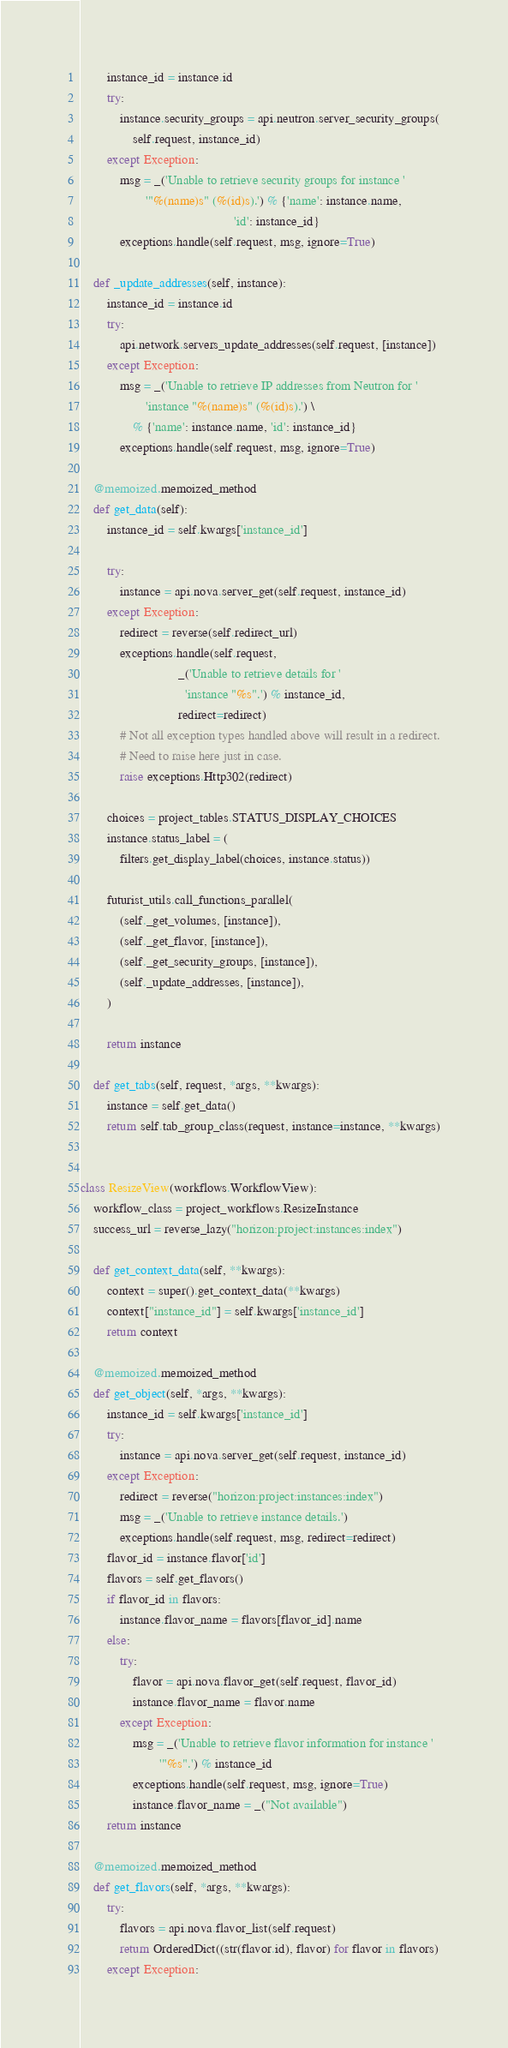<code> <loc_0><loc_0><loc_500><loc_500><_Python_>        instance_id = instance.id
        try:
            instance.security_groups = api.neutron.server_security_groups(
                self.request, instance_id)
        except Exception:
            msg = _('Unable to retrieve security groups for instance '
                    '"%(name)s" (%(id)s).') % {'name': instance.name,
                                               'id': instance_id}
            exceptions.handle(self.request, msg, ignore=True)

    def _update_addresses(self, instance):
        instance_id = instance.id
        try:
            api.network.servers_update_addresses(self.request, [instance])
        except Exception:
            msg = _('Unable to retrieve IP addresses from Neutron for '
                    'instance "%(name)s" (%(id)s).') \
                % {'name': instance.name, 'id': instance_id}
            exceptions.handle(self.request, msg, ignore=True)

    @memoized.memoized_method
    def get_data(self):
        instance_id = self.kwargs['instance_id']

        try:
            instance = api.nova.server_get(self.request, instance_id)
        except Exception:
            redirect = reverse(self.redirect_url)
            exceptions.handle(self.request,
                              _('Unable to retrieve details for '
                                'instance "%s".') % instance_id,
                              redirect=redirect)
            # Not all exception types handled above will result in a redirect.
            # Need to raise here just in case.
            raise exceptions.Http302(redirect)

        choices = project_tables.STATUS_DISPLAY_CHOICES
        instance.status_label = (
            filters.get_display_label(choices, instance.status))

        futurist_utils.call_functions_parallel(
            (self._get_volumes, [instance]),
            (self._get_flavor, [instance]),
            (self._get_security_groups, [instance]),
            (self._update_addresses, [instance]),
        )

        return instance

    def get_tabs(self, request, *args, **kwargs):
        instance = self.get_data()
        return self.tab_group_class(request, instance=instance, **kwargs)


class ResizeView(workflows.WorkflowView):
    workflow_class = project_workflows.ResizeInstance
    success_url = reverse_lazy("horizon:project:instances:index")

    def get_context_data(self, **kwargs):
        context = super().get_context_data(**kwargs)
        context["instance_id"] = self.kwargs['instance_id']
        return context

    @memoized.memoized_method
    def get_object(self, *args, **kwargs):
        instance_id = self.kwargs['instance_id']
        try:
            instance = api.nova.server_get(self.request, instance_id)
        except Exception:
            redirect = reverse("horizon:project:instances:index")
            msg = _('Unable to retrieve instance details.')
            exceptions.handle(self.request, msg, redirect=redirect)
        flavor_id = instance.flavor['id']
        flavors = self.get_flavors()
        if flavor_id in flavors:
            instance.flavor_name = flavors[flavor_id].name
        else:
            try:
                flavor = api.nova.flavor_get(self.request, flavor_id)
                instance.flavor_name = flavor.name
            except Exception:
                msg = _('Unable to retrieve flavor information for instance '
                        '"%s".') % instance_id
                exceptions.handle(self.request, msg, ignore=True)
                instance.flavor_name = _("Not available")
        return instance

    @memoized.memoized_method
    def get_flavors(self, *args, **kwargs):
        try:
            flavors = api.nova.flavor_list(self.request)
            return OrderedDict((str(flavor.id), flavor) for flavor in flavors)
        except Exception:</code> 